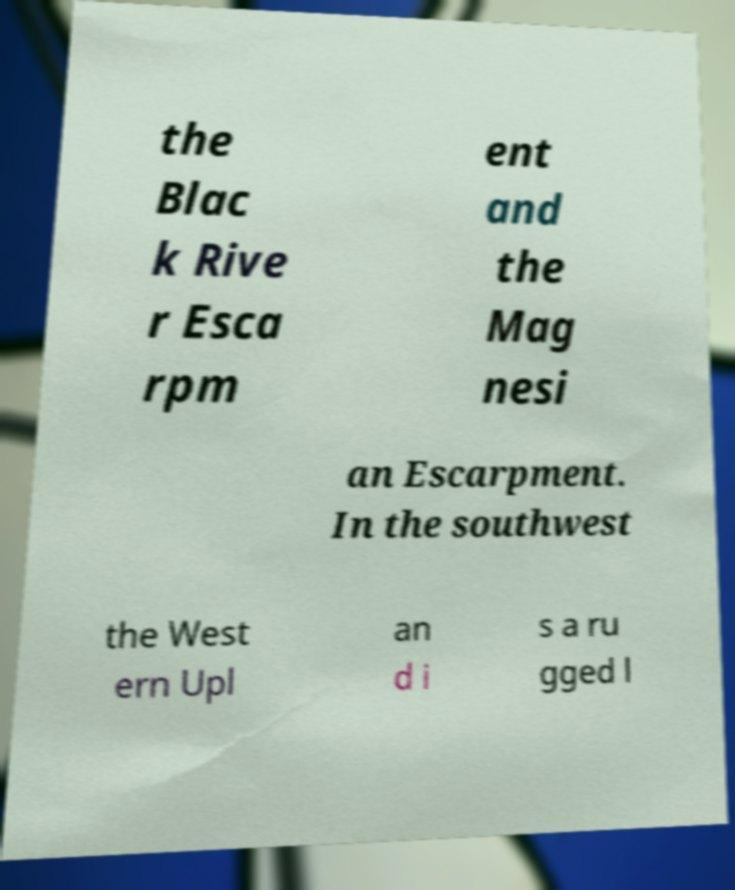For documentation purposes, I need the text within this image transcribed. Could you provide that? the Blac k Rive r Esca rpm ent and the Mag nesi an Escarpment. In the southwest the West ern Upl an d i s a ru gged l 